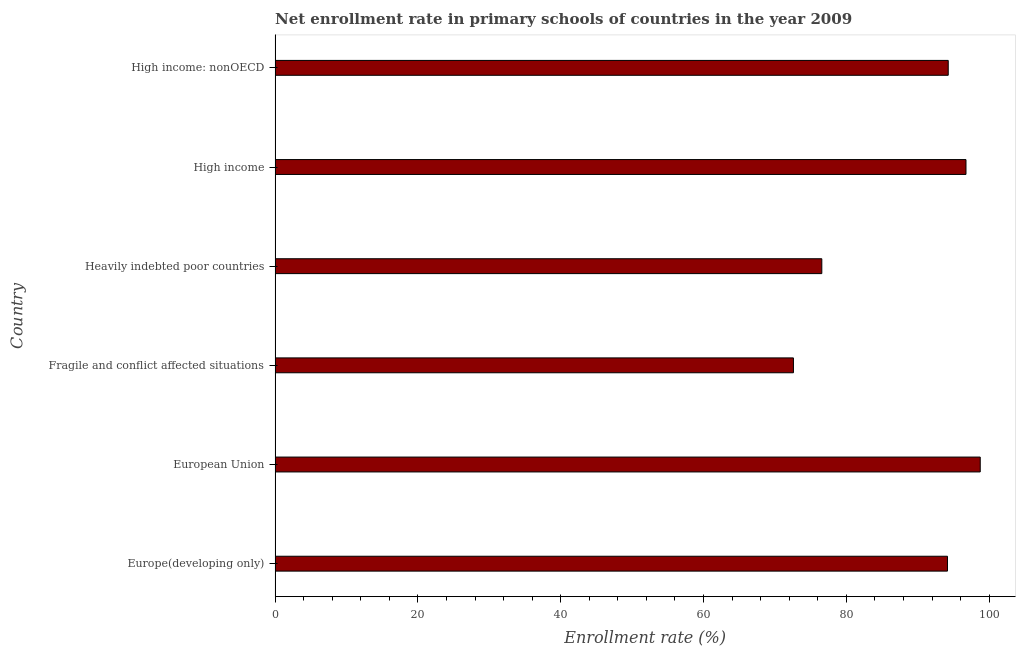Does the graph contain any zero values?
Provide a succinct answer. No. What is the title of the graph?
Keep it short and to the point. Net enrollment rate in primary schools of countries in the year 2009. What is the label or title of the X-axis?
Offer a terse response. Enrollment rate (%). What is the net enrollment rate in primary schools in European Union?
Your answer should be very brief. 98.75. Across all countries, what is the maximum net enrollment rate in primary schools?
Your answer should be very brief. 98.75. Across all countries, what is the minimum net enrollment rate in primary schools?
Your answer should be compact. 72.59. In which country was the net enrollment rate in primary schools minimum?
Provide a short and direct response. Fragile and conflict affected situations. What is the sum of the net enrollment rate in primary schools?
Provide a succinct answer. 533.08. What is the difference between the net enrollment rate in primary schools in European Union and High income: nonOECD?
Offer a very short reply. 4.48. What is the average net enrollment rate in primary schools per country?
Ensure brevity in your answer.  88.85. What is the median net enrollment rate in primary schools?
Give a very brief answer. 94.21. In how many countries, is the net enrollment rate in primary schools greater than 24 %?
Your answer should be very brief. 6. What is the ratio of the net enrollment rate in primary schools in Fragile and conflict affected situations to that in High income: nonOECD?
Ensure brevity in your answer.  0.77. Is the difference between the net enrollment rate in primary schools in European Union and High income: nonOECD greater than the difference between any two countries?
Your answer should be very brief. No. What is the difference between the highest and the second highest net enrollment rate in primary schools?
Ensure brevity in your answer.  2. Is the sum of the net enrollment rate in primary schools in Fragile and conflict affected situations and High income greater than the maximum net enrollment rate in primary schools across all countries?
Your answer should be compact. Yes. What is the difference between the highest and the lowest net enrollment rate in primary schools?
Provide a succinct answer. 26.16. How many bars are there?
Ensure brevity in your answer.  6. How many countries are there in the graph?
Your response must be concise. 6. What is the Enrollment rate (%) of Europe(developing only)?
Your answer should be very brief. 94.16. What is the Enrollment rate (%) of European Union?
Provide a succinct answer. 98.75. What is the Enrollment rate (%) in Fragile and conflict affected situations?
Your answer should be compact. 72.59. What is the Enrollment rate (%) of Heavily indebted poor countries?
Offer a very short reply. 76.56. What is the Enrollment rate (%) of High income?
Offer a terse response. 96.75. What is the Enrollment rate (%) in High income: nonOECD?
Your response must be concise. 94.27. What is the difference between the Enrollment rate (%) in Europe(developing only) and European Union?
Make the answer very short. -4.59. What is the difference between the Enrollment rate (%) in Europe(developing only) and Fragile and conflict affected situations?
Your answer should be compact. 21.57. What is the difference between the Enrollment rate (%) in Europe(developing only) and Heavily indebted poor countries?
Ensure brevity in your answer.  17.6. What is the difference between the Enrollment rate (%) in Europe(developing only) and High income?
Give a very brief answer. -2.59. What is the difference between the Enrollment rate (%) in Europe(developing only) and High income: nonOECD?
Keep it short and to the point. -0.11. What is the difference between the Enrollment rate (%) in European Union and Fragile and conflict affected situations?
Your answer should be compact. 26.16. What is the difference between the Enrollment rate (%) in European Union and Heavily indebted poor countries?
Provide a succinct answer. 22.18. What is the difference between the Enrollment rate (%) in European Union and High income?
Ensure brevity in your answer.  2. What is the difference between the Enrollment rate (%) in European Union and High income: nonOECD?
Provide a short and direct response. 4.48. What is the difference between the Enrollment rate (%) in Fragile and conflict affected situations and Heavily indebted poor countries?
Make the answer very short. -3.97. What is the difference between the Enrollment rate (%) in Fragile and conflict affected situations and High income?
Provide a succinct answer. -24.16. What is the difference between the Enrollment rate (%) in Fragile and conflict affected situations and High income: nonOECD?
Give a very brief answer. -21.68. What is the difference between the Enrollment rate (%) in Heavily indebted poor countries and High income?
Make the answer very short. -20.19. What is the difference between the Enrollment rate (%) in Heavily indebted poor countries and High income: nonOECD?
Offer a terse response. -17.7. What is the difference between the Enrollment rate (%) in High income and High income: nonOECD?
Your response must be concise. 2.48. What is the ratio of the Enrollment rate (%) in Europe(developing only) to that in European Union?
Provide a succinct answer. 0.95. What is the ratio of the Enrollment rate (%) in Europe(developing only) to that in Fragile and conflict affected situations?
Keep it short and to the point. 1.3. What is the ratio of the Enrollment rate (%) in Europe(developing only) to that in Heavily indebted poor countries?
Your answer should be compact. 1.23. What is the ratio of the Enrollment rate (%) in Europe(developing only) to that in High income?
Provide a succinct answer. 0.97. What is the ratio of the Enrollment rate (%) in European Union to that in Fragile and conflict affected situations?
Give a very brief answer. 1.36. What is the ratio of the Enrollment rate (%) in European Union to that in Heavily indebted poor countries?
Keep it short and to the point. 1.29. What is the ratio of the Enrollment rate (%) in European Union to that in High income?
Your answer should be very brief. 1.02. What is the ratio of the Enrollment rate (%) in European Union to that in High income: nonOECD?
Your answer should be very brief. 1.05. What is the ratio of the Enrollment rate (%) in Fragile and conflict affected situations to that in Heavily indebted poor countries?
Provide a succinct answer. 0.95. What is the ratio of the Enrollment rate (%) in Fragile and conflict affected situations to that in High income?
Offer a very short reply. 0.75. What is the ratio of the Enrollment rate (%) in Fragile and conflict affected situations to that in High income: nonOECD?
Offer a terse response. 0.77. What is the ratio of the Enrollment rate (%) in Heavily indebted poor countries to that in High income?
Make the answer very short. 0.79. What is the ratio of the Enrollment rate (%) in Heavily indebted poor countries to that in High income: nonOECD?
Your answer should be very brief. 0.81. 